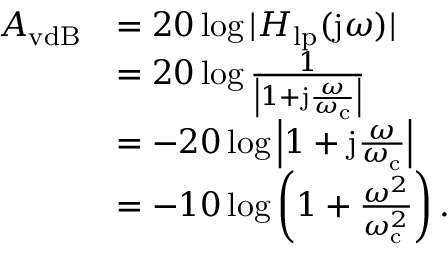<formula> <loc_0><loc_0><loc_500><loc_500>{ \begin{array} { r l } { A _ { v d B } } & { = 2 0 \log | H _ { l p } ( j \omega ) | } \\ & { = 2 0 \log { \frac { 1 } { \left | 1 + j { \frac { \omega } { \omega _ { c } } } \right | } } } \\ & { = - 2 0 \log \left | 1 + j { \frac { \omega } { \omega _ { c } } } \right | } \\ & { = - 1 0 \log \left ( 1 + { \frac { \omega ^ { 2 } } { \omega _ { c } ^ { 2 } } } \right ) . } \end{array} }</formula> 